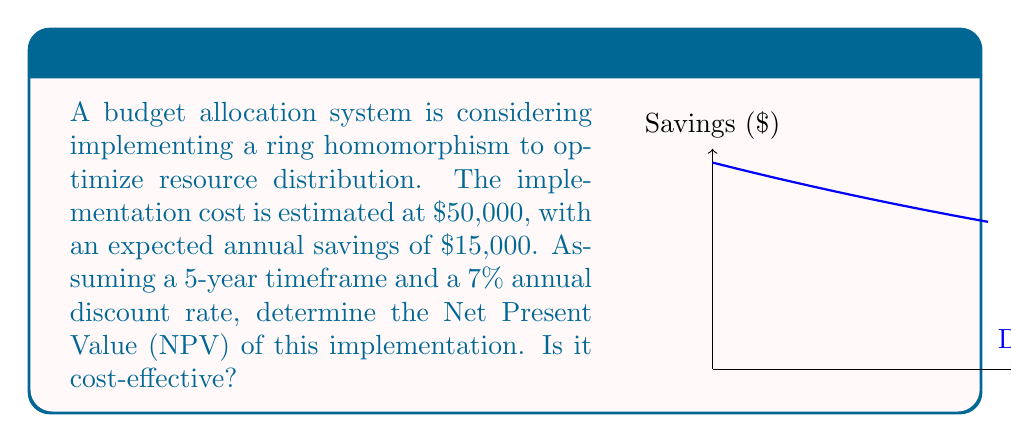What is the answer to this math problem? To determine the cost-effectiveness, we need to calculate the Net Present Value (NPV) of the implementation:

1. Initial cost: $C_0 = -$50,000

2. Annual savings: $S = $15,000

3. Discount rate: $r = 7\% = 0.07$

4. Timeframe: $n = 5$ years

The NPV formula is:

$$NPV = C_0 + \sum_{t=1}^n \frac{S_t}{(1+r)^t}$$

Where $S_t$ is the cash flow at time $t$.

Substituting our values:

$$NPV = -50000 + \sum_{t=1}^5 \frac{15000}{(1+0.07)^t}$$

Calculating each year's discounted savings:
Year 1: $\frac{15000}{1.07^1} = 14018.69$
Year 2: $\frac{15000}{1.07^2} = 13102.51$
Year 3: $\frac{15000}{1.07^3} = 12245.34$
Year 4: $\frac{15000}{1.07^4} = 11443.31$
Year 5: $\frac{15000}{1.07^5} = 10693.75$

Sum of discounted savings: $61503.60$

Final NPV calculation:
$$NPV = -50000 + 61503.60 = 11503.60$$

Since the NPV is positive, the implementation is cost-effective.
Answer: $11,503.60; Yes, it is cost-effective. 